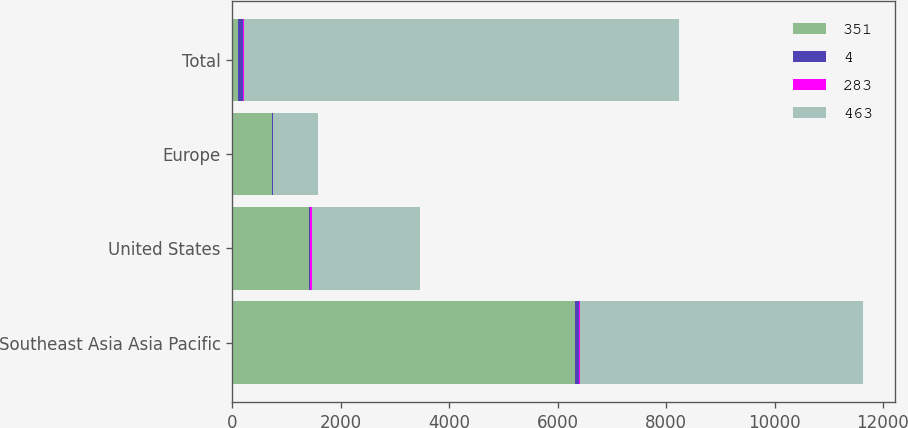<chart> <loc_0><loc_0><loc_500><loc_500><stacked_bar_chart><ecel><fcel>Southeast Asia Asia Pacific<fcel>United States<fcel>Europe<fcel>Total<nl><fcel>351<fcel>6312<fcel>1419<fcel>735<fcel>100<nl><fcel>4<fcel>75<fcel>17<fcel>8<fcel>100<nl><fcel>283<fcel>21<fcel>29<fcel>10<fcel>5<nl><fcel>463<fcel>5225<fcel>1995<fcel>817<fcel>8037<nl></chart> 